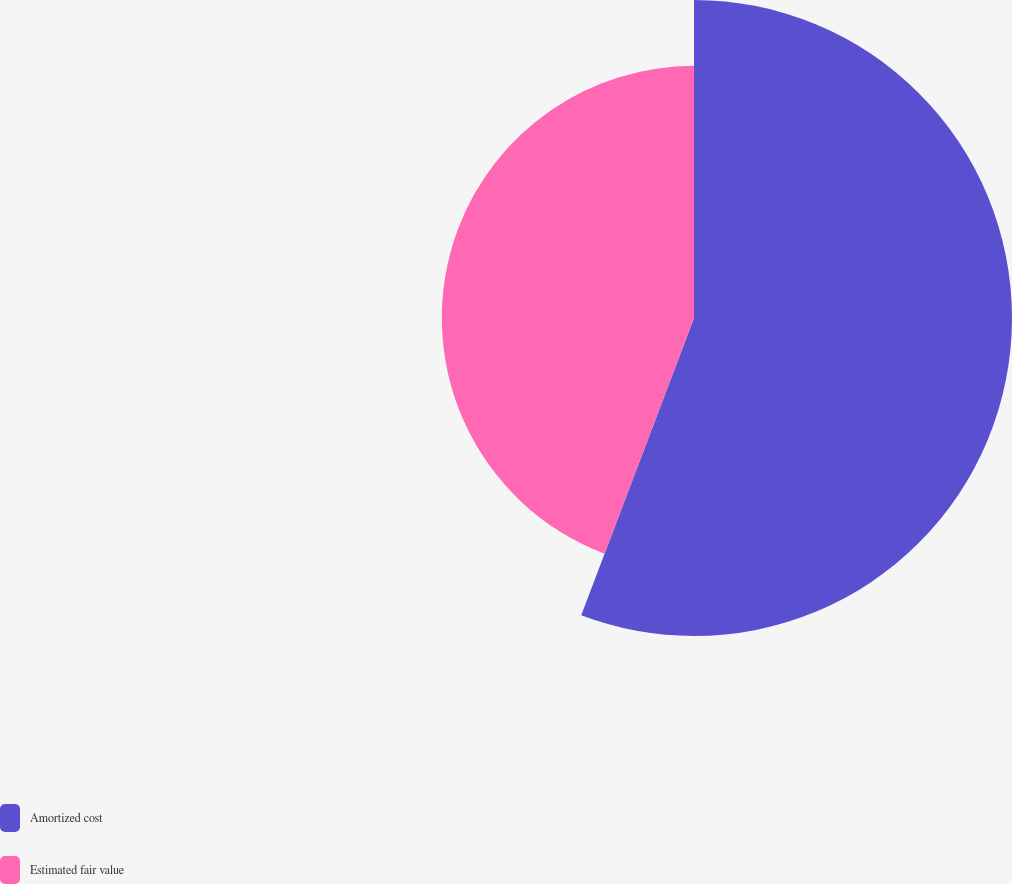Convert chart. <chart><loc_0><loc_0><loc_500><loc_500><pie_chart><fcel>Amortized cost<fcel>Estimated fair value<nl><fcel>55.77%<fcel>44.23%<nl></chart> 